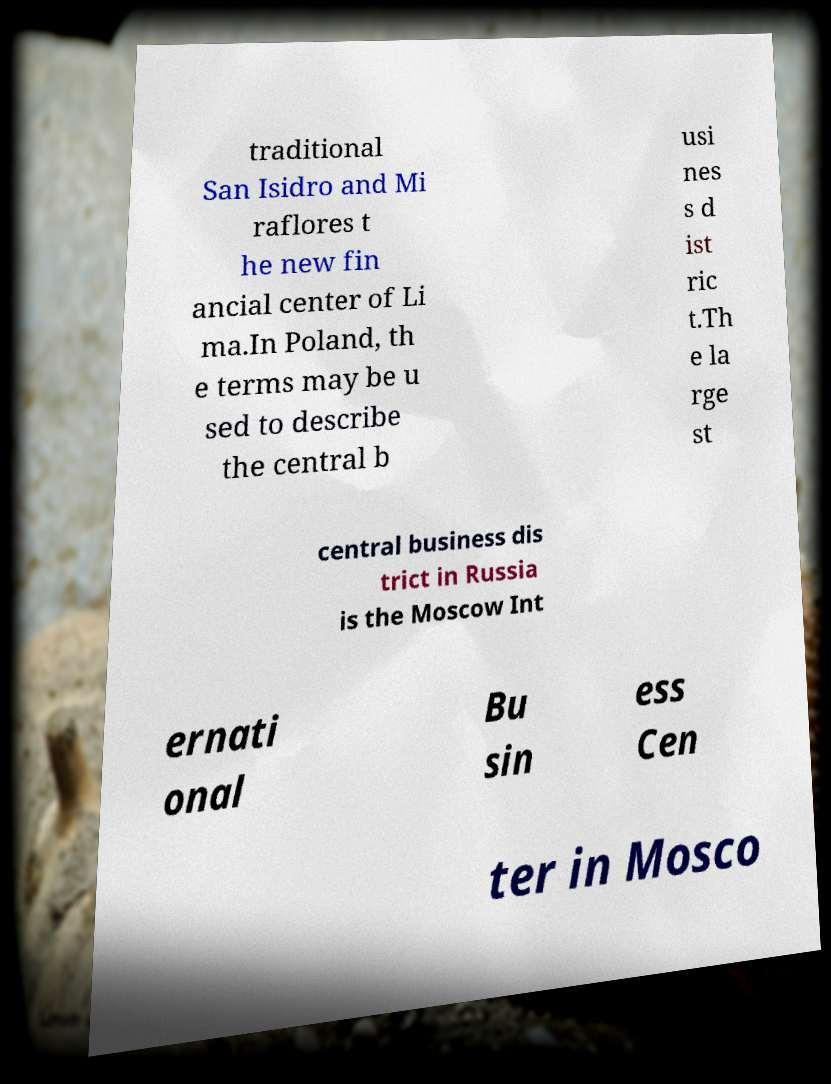Can you accurately transcribe the text from the provided image for me? traditional San Isidro and Mi raflores t he new fin ancial center of Li ma.In Poland, th e terms may be u sed to describe the central b usi nes s d ist ric t.Th e la rge st central business dis trict in Russia is the Moscow Int ernati onal Bu sin ess Cen ter in Mosco 